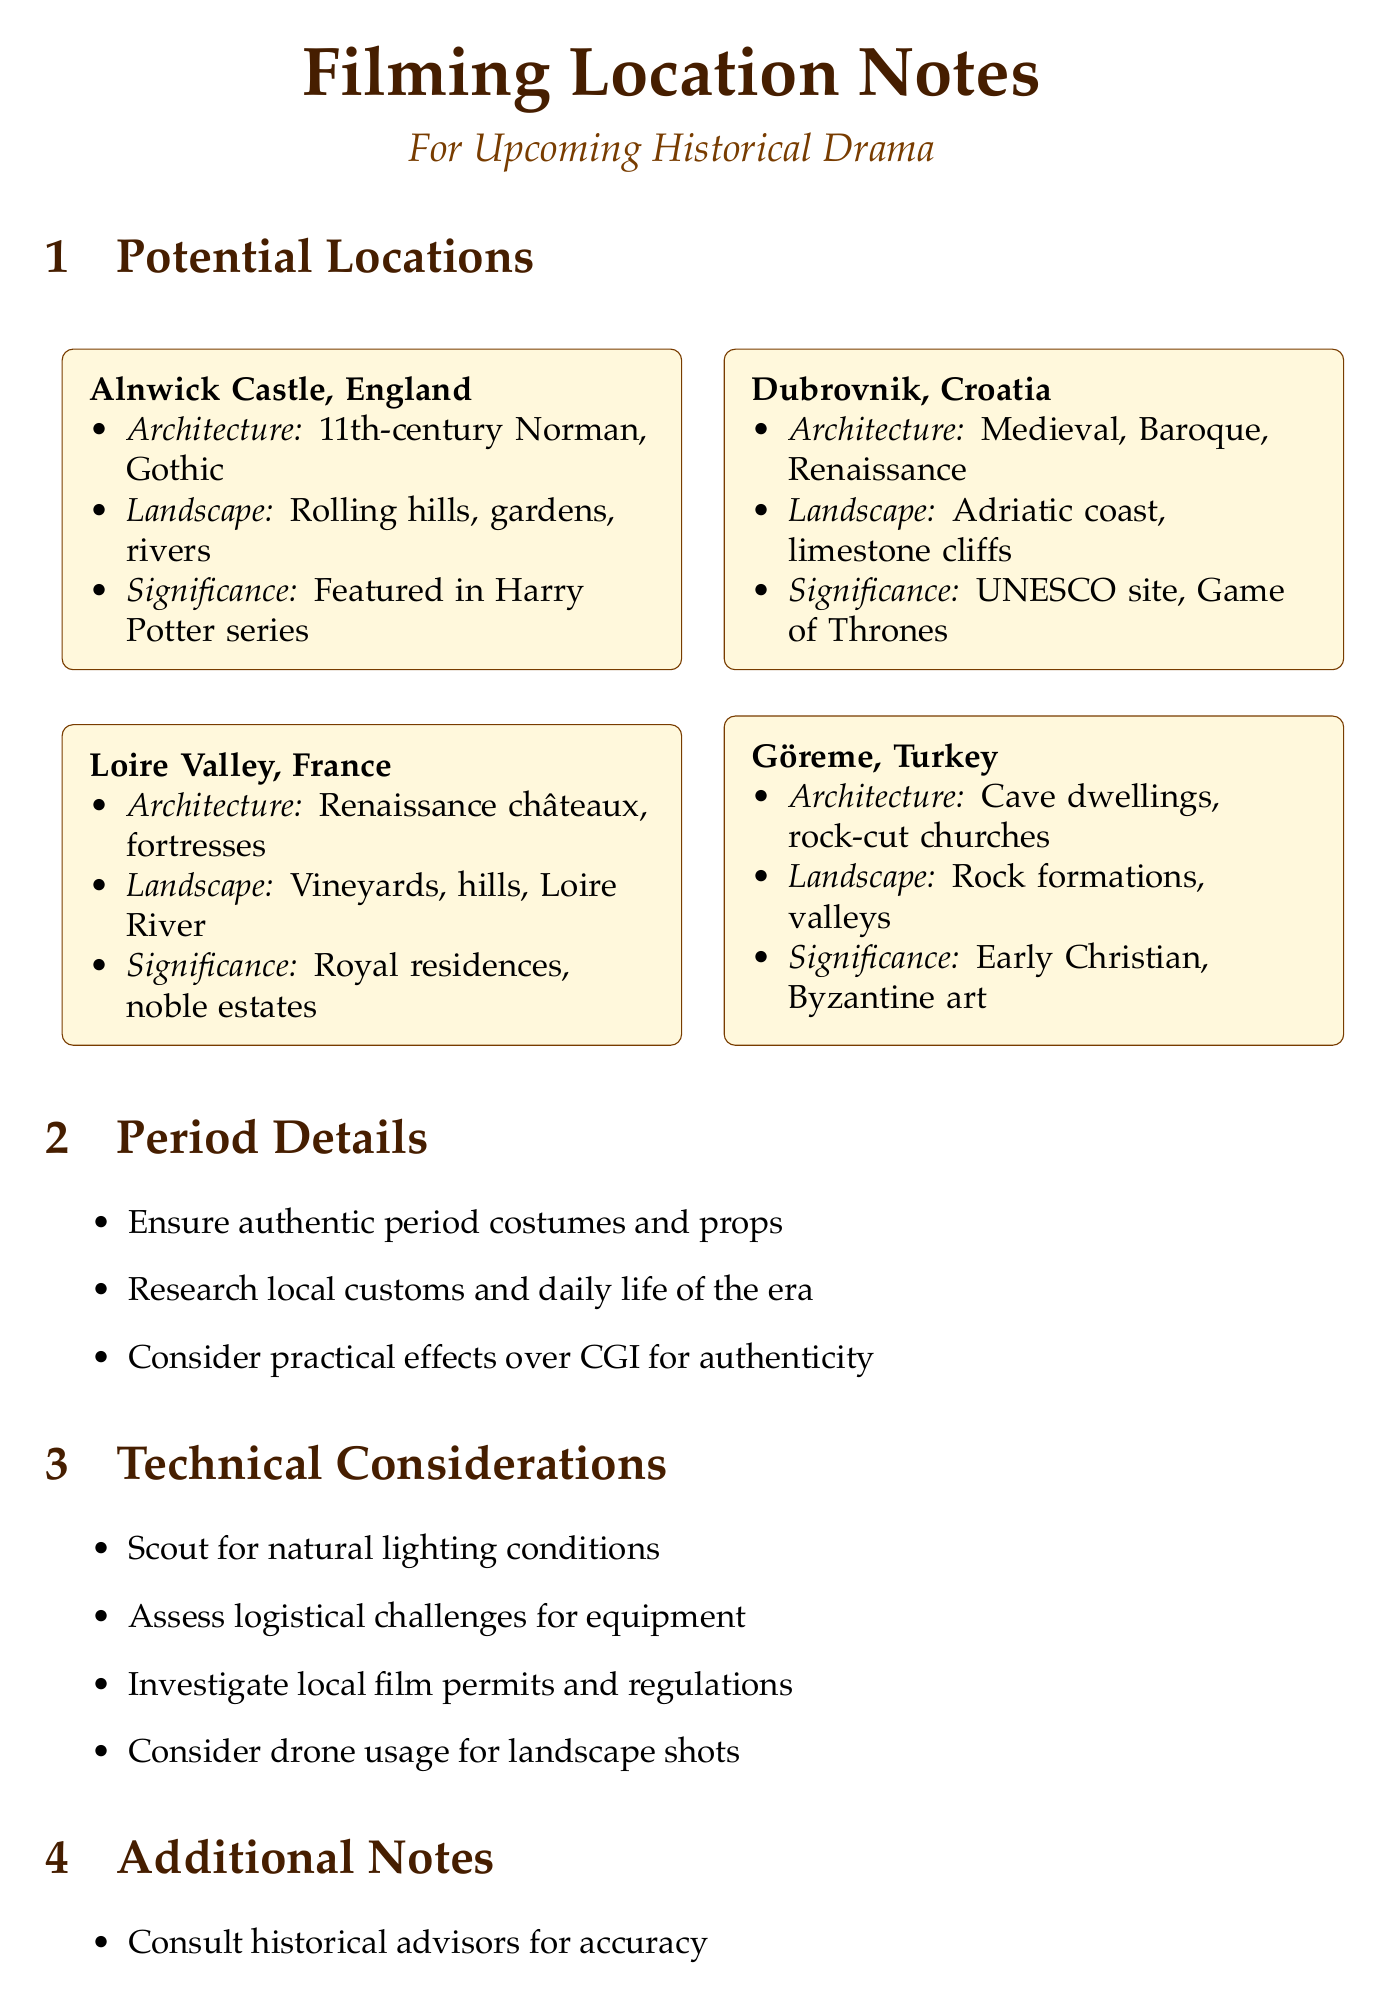What is the architectural style of Alnwick Castle? The architectural style of Alnwick Castle is described as 11th-century Norman architecture with Gothic additions.
Answer: 11th-century Norman architecture, Gothic additions What natural landscape is associated with Dubrovnik? The natural landscape associated with Dubrovnik includes the Adriatic coastline and limestone cliffs.
Answer: Adriatic coastline, limestone cliffs Which significant historical site is located in the Loire Valley? The Loire Valley is home to numerous royal residences and noble estates, marking its historical significance.
Answer: Royal residences and noble estates What unique feature is found in Göreme? Göreme is noted for its unique rock formations and ancient cave dwellings.
Answer: Unique rock formations, ancient cave dwellings Which filming consideration involves local regulations? Investigating local film permits and regulations is a key technical consideration.
Answer: Local film permits and regulations What is the main purpose of consulting historical advisors? The main purpose of consulting historical advisors is to ensure the accuracy of sets and scenes.
Answer: Ensure accuracy of sets and scenes How many potential filming locations are listed? There are a total of four potential filming locations mentioned in the document.
Answer: Four What type of effects should be considered for authenticity? Practical effects over CGI should be considered for authenticity in the film.
Answer: Practical effects over CGI What should be planned for outdoor shoots? Weather contingencies should be planned for outdoor shoots.
Answer: Weather contingencies 